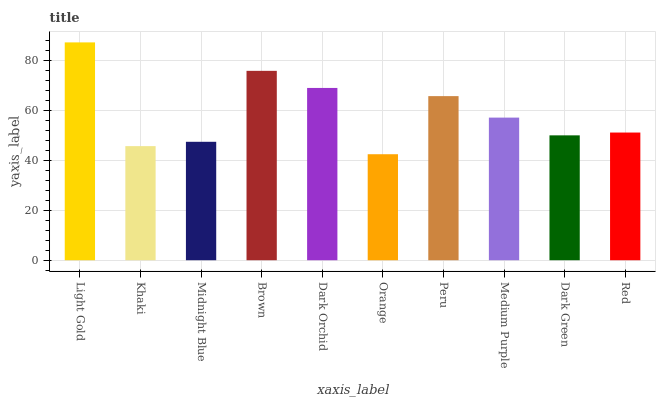Is Light Gold the maximum?
Answer yes or no. Yes. Is Khaki the minimum?
Answer yes or no. No. Is Khaki the maximum?
Answer yes or no. No. Is Light Gold greater than Khaki?
Answer yes or no. Yes. Is Khaki less than Light Gold?
Answer yes or no. Yes. Is Khaki greater than Light Gold?
Answer yes or no. No. Is Light Gold less than Khaki?
Answer yes or no. No. Is Medium Purple the high median?
Answer yes or no. Yes. Is Red the low median?
Answer yes or no. Yes. Is Dark Green the high median?
Answer yes or no. No. Is Orange the low median?
Answer yes or no. No. 